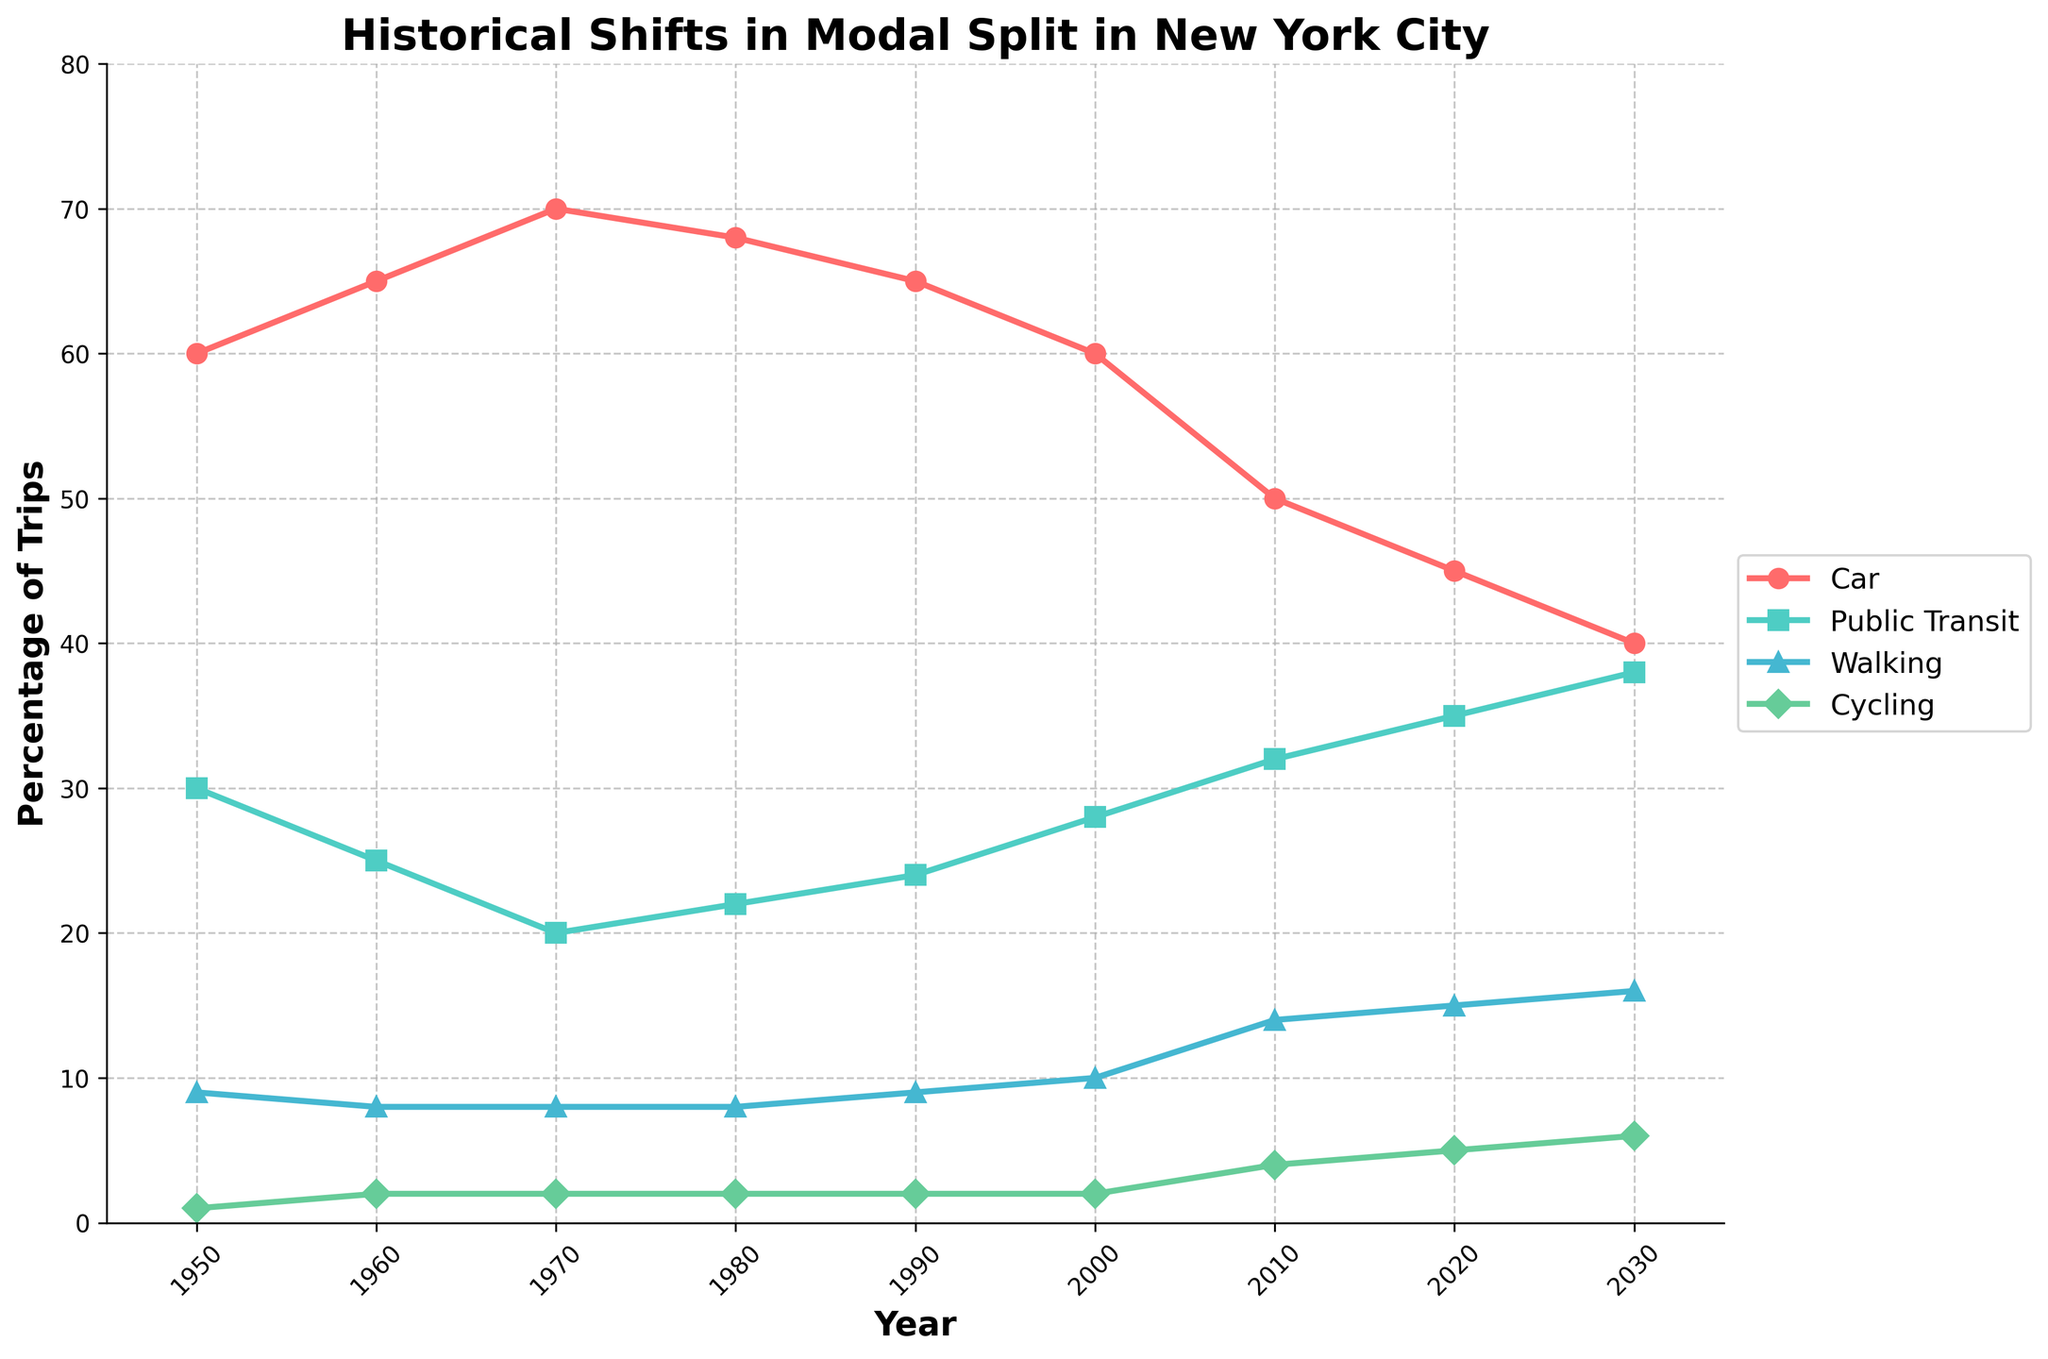Which mode of transport had the highest percentage of trips in 1970? In 1970, the percentage of trips by each mode is: Car (70%), Public Transit (20%), Walking (8%), Cycling (2%). Hence, Car had the highest percentage.
Answer: Car How did the percentage of trips by cycling change from 2010 to 2030? The plot shows the percentage of trips by cycling in 2010 as 4% and in 2030 as 6%. The change is 6% - 4% = 2%.
Answer: Increased by 2% What is the difference in the percentage of trips by walking between 1950 and 2020? In 1950, the percentage of trips by walking is 9%, whereas in 2020, it is 15%. The difference is 15% - 9% = 6%.
Answer: 6% Which mode of transport shows a consistent increase from 1950 to 2030? By tracking each line, we see that the percentage of trips by Public Transit and Cycling generally increase over this period.
Answer: Public Transit and Cycling In which decade did the percentage of trips by cars first start to decrease? The percentage of trips by cars increased until 1970 and then started to decrease from 1970 to 1980.
Answer: 1970s By how much did the percentage of trips by public transit increase from 2000 to 2020? The figure shows the public transit percentages as 28% in 2000 and 35% in 2020. The increase is 35% - 28% = 7%.
Answer: 7% Compare the percentage of trips by cycling in 1990 and 2010. Which year had a higher percentage and by how much? In 1990, the percentage of trips by cycling was 2% and in 2010 it was 4%. 2010 had a higher percentage by 4% - 2% = 2%.
Answer: 2010 by 2% What is the trend for the percentage of trips by walking from 2000 to 2030? From the plot, the percentage of trips by walking increased from 10% in 2000 to 16% in 2030.
Answer: Increasing What can be said about the total percentage of trips by public transit and walking together in 1990? In 1990, the percentage of trips by public transit is 24% and walking is 9%. The total is 24% + 9% = 33%.
Answer: 33% How did the percentage of trips by car change from 1980 to 2000? The chart shows the percentage of trips by car in 1980 as 68% and in 2000 as 60%. The change is 60% - 68% = -8%.
Answer: Decreased by 8% 